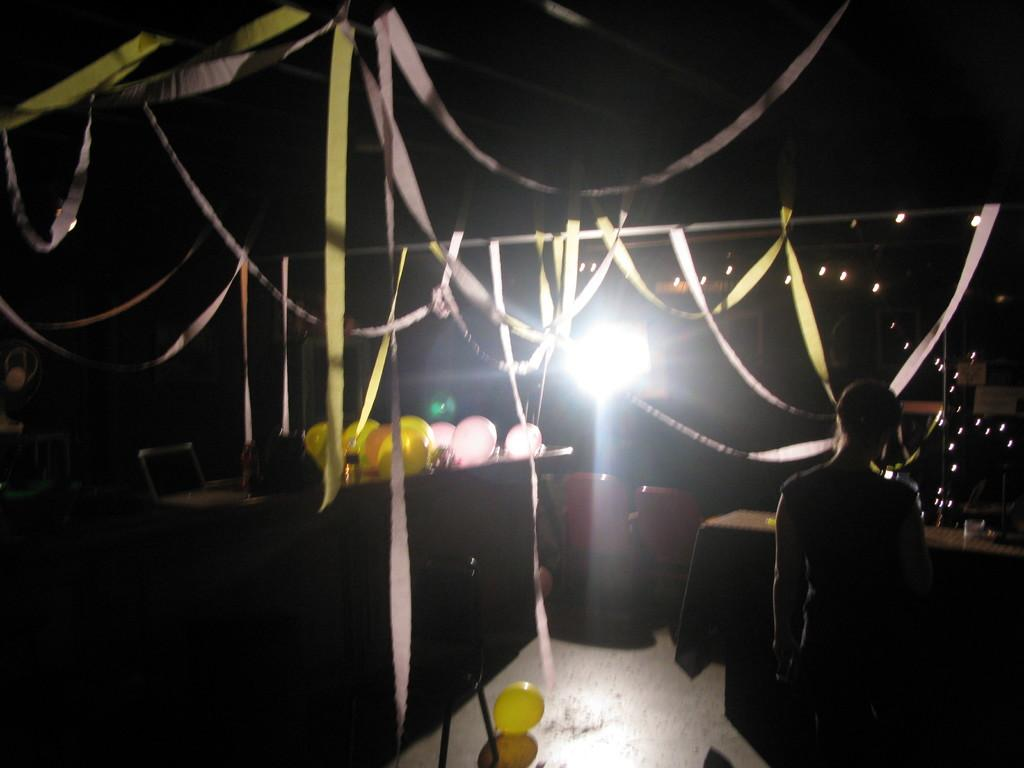Who or what is present in the image? There is a person in the image. What can be seen in the background or surrounding the person? There are balloons, chairs, decorations, lights, and a table visible in the image. Can you describe the decorations at the top of the image? The decorations visible at the top of the image are not specified, but they are likely related to the event or setting. What type of furniture is present in the image? Chairs and a table are present in the image. What type of noise can be heard coming from the copper in the image? There is no copper present in the image, and therefore no noise can be heard from it. 